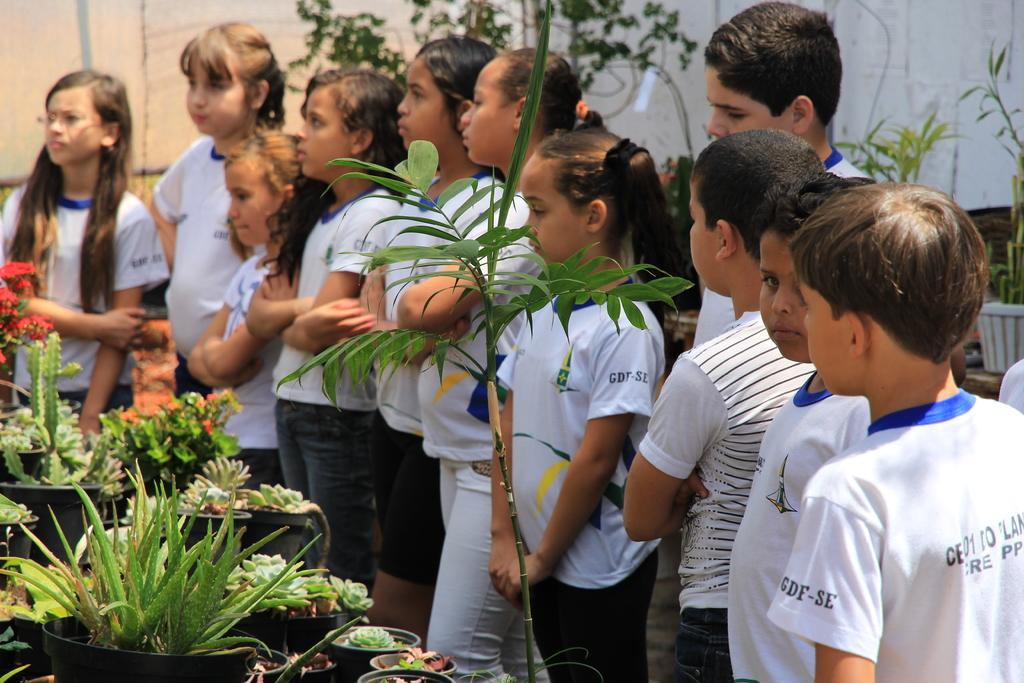Can you describe this image briefly? This image consists of many children. They are wearing white T-shirts. On the left, there are potted plants. In the background, we can see a wall along with the plants. 